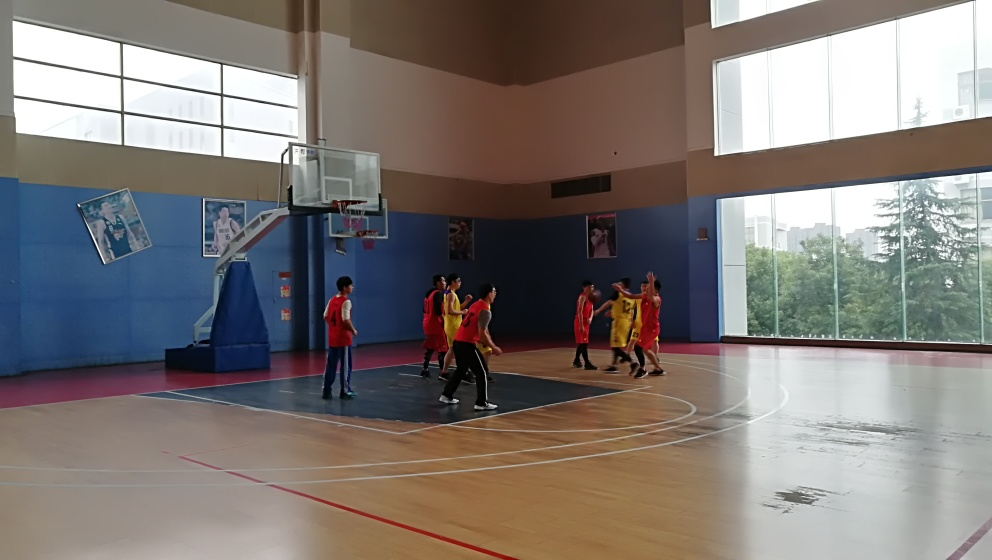Tell me about the colors and design of the court. The basketball court displays a classic design with a polished wood floor, marked with crisply painted lines that define boundaries and key areas. The high contrast between the court lines and the wooden floor provides clear visual guidance for the players. The walls are painted in two shades of blue, adding to the vibrant yet not overwhelming palette of the gym. Does the setting seem well-maintained? Yes, the condition of the court and the clarity of the markings suggest that the facility is well-maintained. Regular upkeep appears to be a priority here, ensuring a safe and appealing environment for sports activities. 